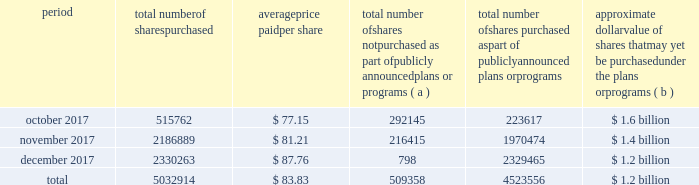Table of contents the table discloses purchases of shares of our common stock made by us or on our behalf during the fourth quarter of 2017 .
Period total number of shares purchased average price paid per share total number of shares not purchased as part of publicly announced plans or programs ( a ) total number of shares purchased as part of publicly announced plans or programs approximate dollar value of shares that may yet be purchased under the plans or programs ( b ) .
( a ) the shares reported in this column represent purchases settled in the fourth quarter of 2017 relating to ( i ) our purchases of shares in open-market transactions to meet our obligations under stock-based compensation plans , and ( ii ) our purchases of shares from our employees and non-employee directors in connection with the exercise of stock options , the vesting of restricted stock , and other stock compensation transactions in accordance with the terms of our stock-based compensation plans .
( b ) on september 21 , 2016 , we announced that our board of directors authorized our purchase of up to $ 2.5 billion of our outstanding common stock ( the 2016 program ) with no expiration date .
As of december 31 , 2017 , we had $ 1.2 billion remaining available for purchase under the 2016 program .
On january 23 , 2018 , we announced that our board of directors authorized our purchase of up to an additional $ 2.5 billion of our outstanding common stock with no expiration date. .
As of december 31 , 2017 , what was the percent of the 2016 program remaining available for purchase? 
Computations: (1.2 / 2.5)
Answer: 0.48. 